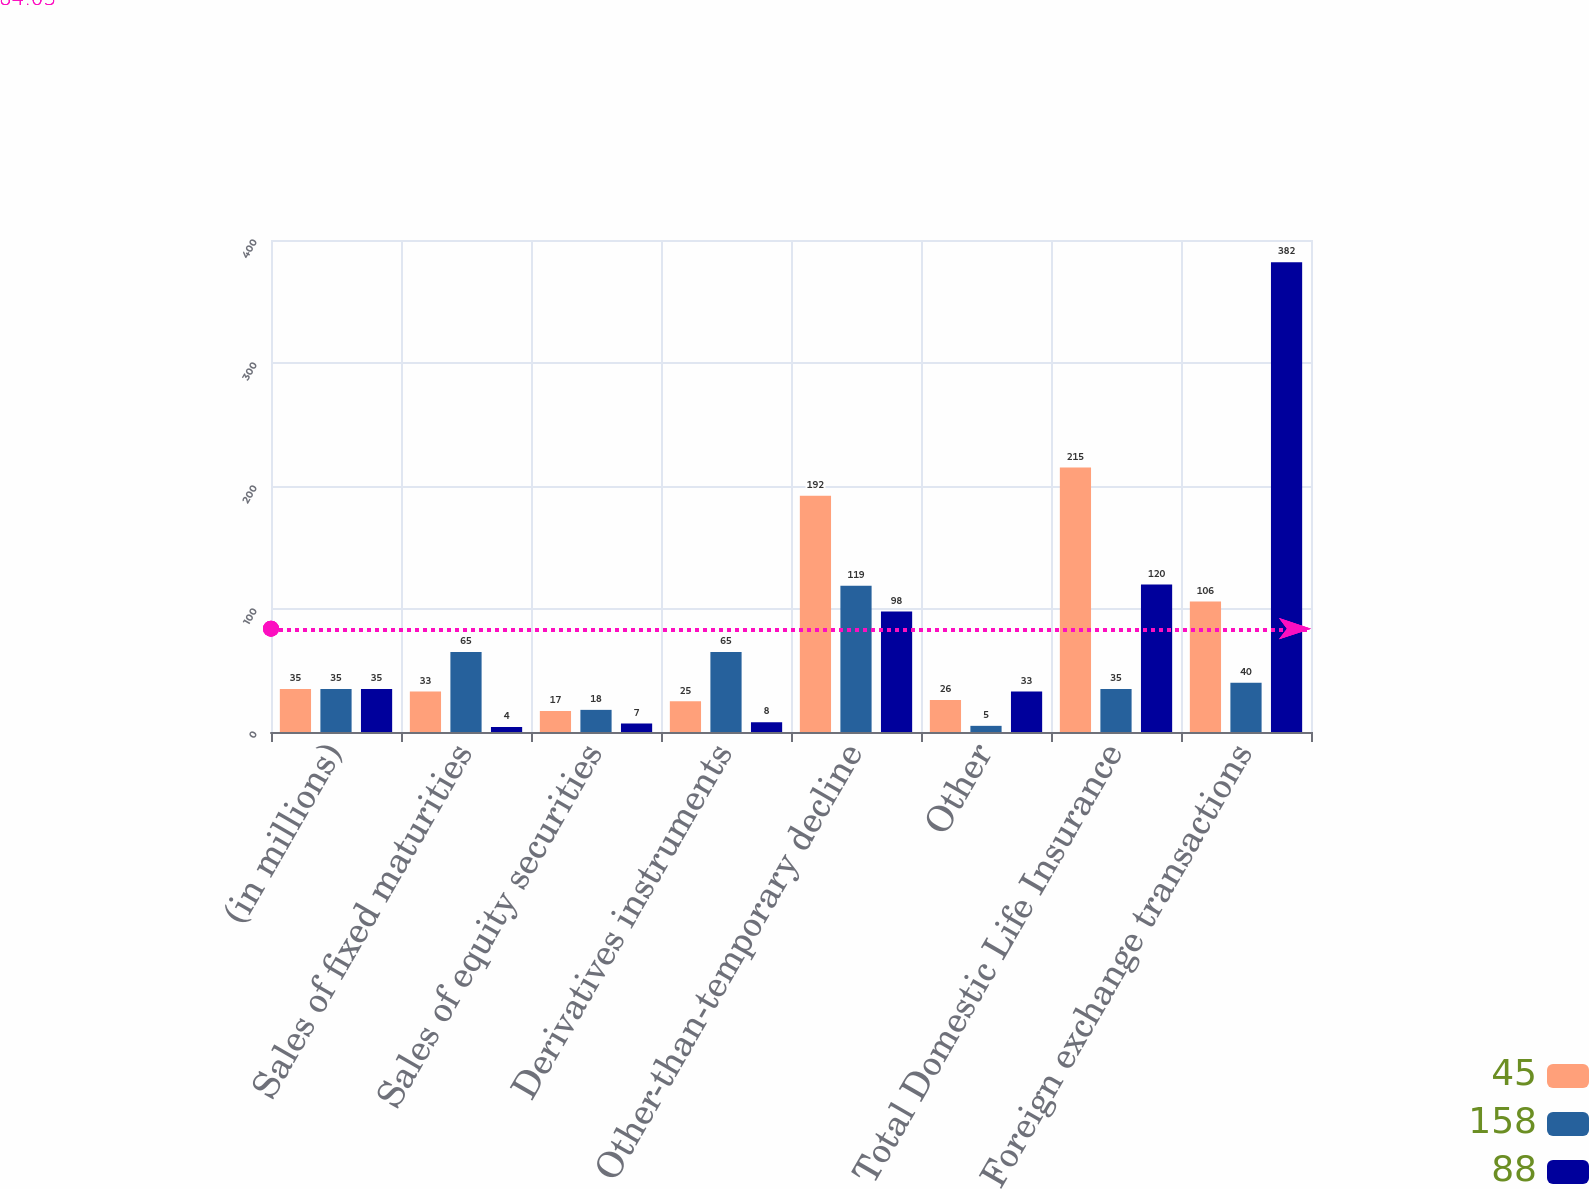<chart> <loc_0><loc_0><loc_500><loc_500><stacked_bar_chart><ecel><fcel>(in millions)<fcel>Sales of fixed maturities<fcel>Sales of equity securities<fcel>Derivatives instruments<fcel>Other-than-temporary decline<fcel>Other<fcel>Total Domestic Life Insurance<fcel>Foreign exchange transactions<nl><fcel>45<fcel>35<fcel>33<fcel>17<fcel>25<fcel>192<fcel>26<fcel>215<fcel>106<nl><fcel>158<fcel>35<fcel>65<fcel>18<fcel>65<fcel>119<fcel>5<fcel>35<fcel>40<nl><fcel>88<fcel>35<fcel>4<fcel>7<fcel>8<fcel>98<fcel>33<fcel>120<fcel>382<nl></chart> 